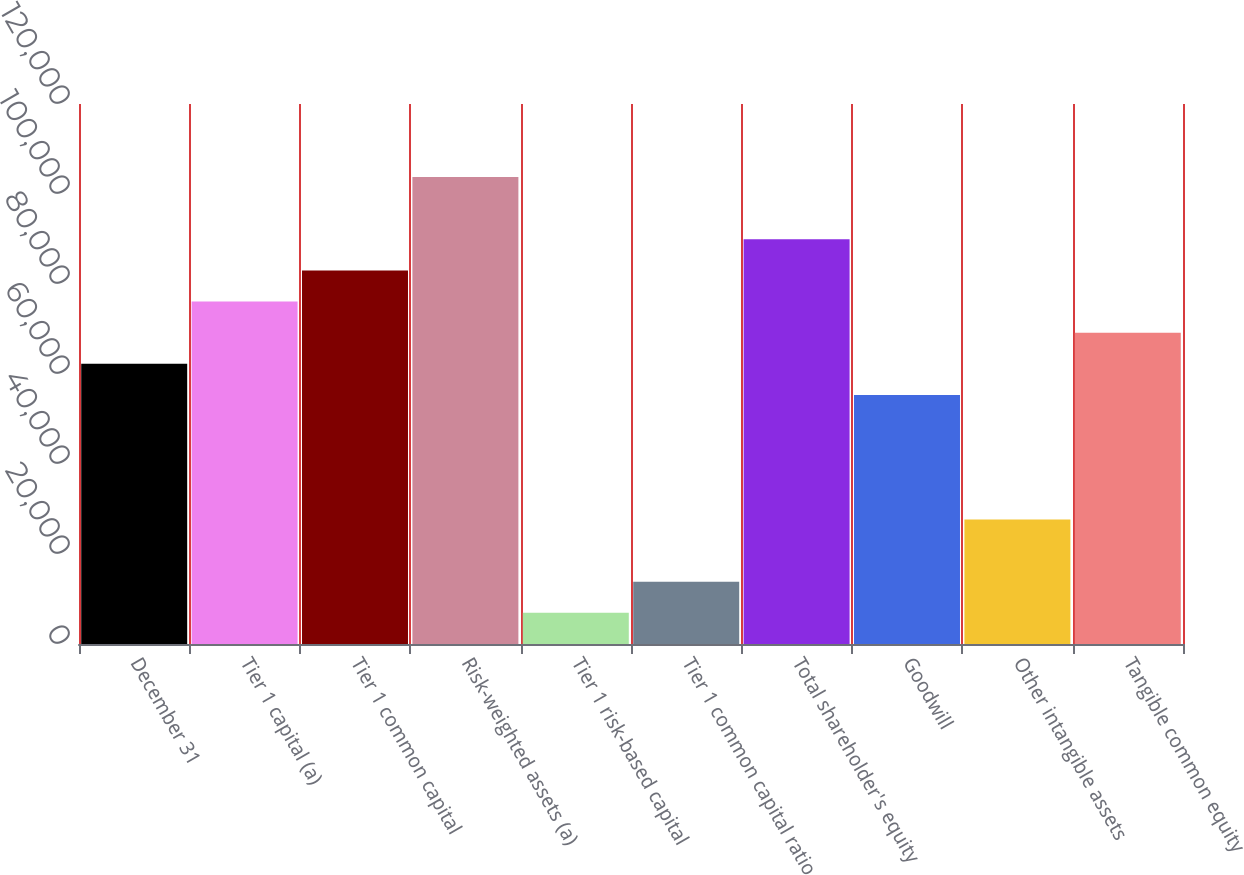Convert chart to OTSL. <chart><loc_0><loc_0><loc_500><loc_500><bar_chart><fcel>December 31<fcel>Tier 1 capital (a)<fcel>Tier 1 common capital<fcel>Risk-weighted assets (a)<fcel>Tier 1 risk-based capital<fcel>Tier 1 common capital ratio<fcel>Total shareholder's equity<fcel>Goodwill<fcel>Other intangible assets<fcel>Tangible common equity<nl><fcel>62272<fcel>76108<fcel>83026<fcel>103780<fcel>6927.86<fcel>13845.9<fcel>89944<fcel>55354<fcel>27681.9<fcel>69190<nl></chart> 